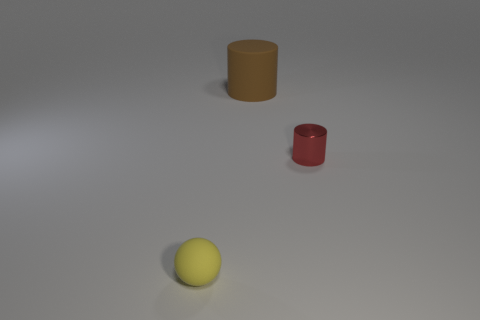Add 3 red rubber blocks. How many objects exist? 6 Subtract all spheres. How many objects are left? 2 Subtract all large brown rubber cylinders. Subtract all red metal objects. How many objects are left? 1 Add 2 large cylinders. How many large cylinders are left? 3 Add 1 brown metal cylinders. How many brown metal cylinders exist? 1 Subtract 1 brown cylinders. How many objects are left? 2 